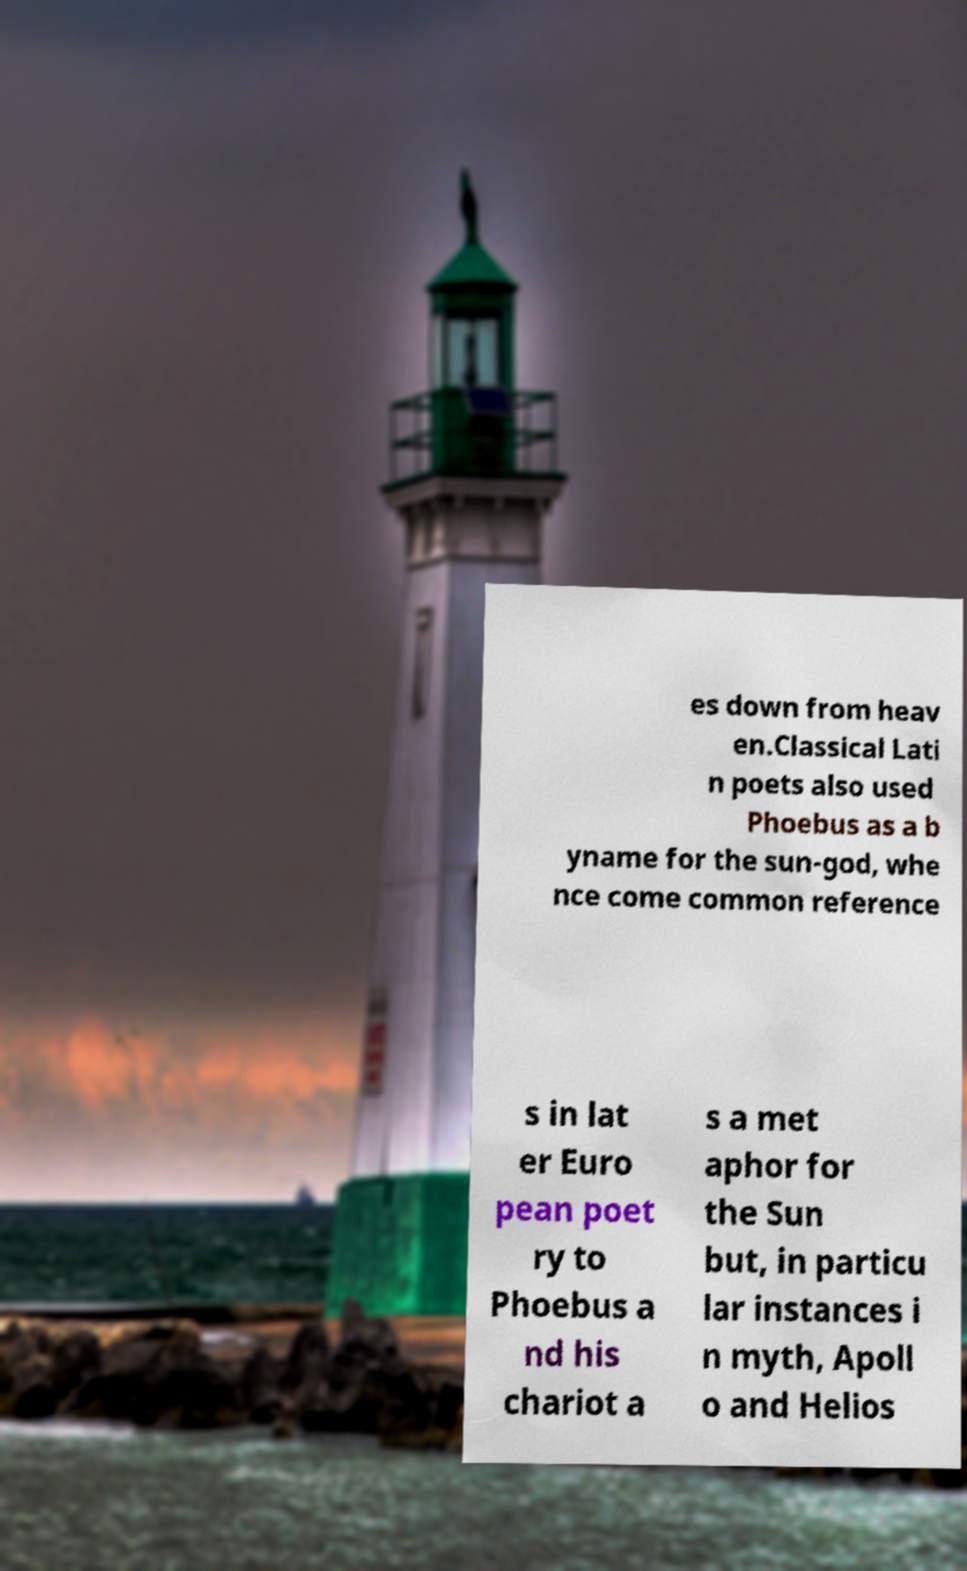Could you assist in decoding the text presented in this image and type it out clearly? es down from heav en.Classical Lati n poets also used Phoebus as a b yname for the sun-god, whe nce come common reference s in lat er Euro pean poet ry to Phoebus a nd his chariot a s a met aphor for the Sun but, in particu lar instances i n myth, Apoll o and Helios 